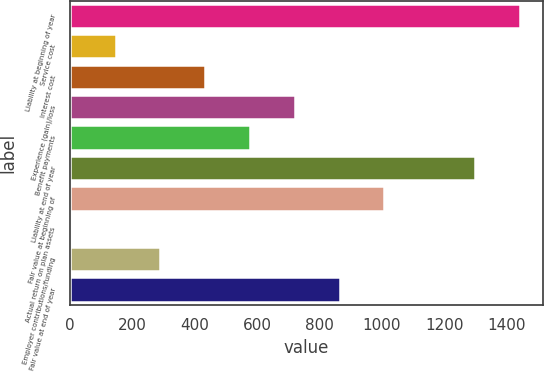Convert chart to OTSL. <chart><loc_0><loc_0><loc_500><loc_500><bar_chart><fcel>Liability at beginning of year<fcel>Service cost<fcel>Interest cost<fcel>Experience (gain)/loss<fcel>Benefit payments<fcel>Liability at end of year<fcel>Fair value at beginning of<fcel>Actual return on plan assets<fcel>Employer contributions/funding<fcel>Fair value at end of year<nl><fcel>1443.7<fcel>145.7<fcel>433.1<fcel>720.5<fcel>576.8<fcel>1300<fcel>1007.9<fcel>2<fcel>289.4<fcel>864.2<nl></chart> 